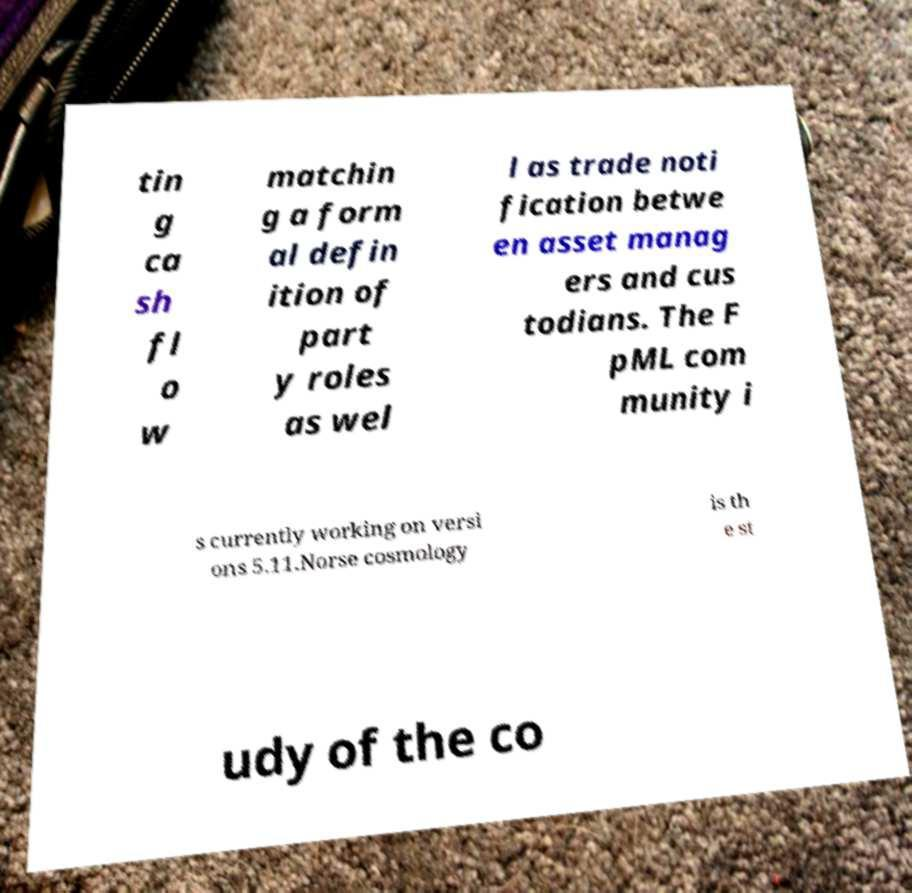Could you extract and type out the text from this image? tin g ca sh fl o w matchin g a form al defin ition of part y roles as wel l as trade noti fication betwe en asset manag ers and cus todians. The F pML com munity i s currently working on versi ons 5.11.Norse cosmology is th e st udy of the co 